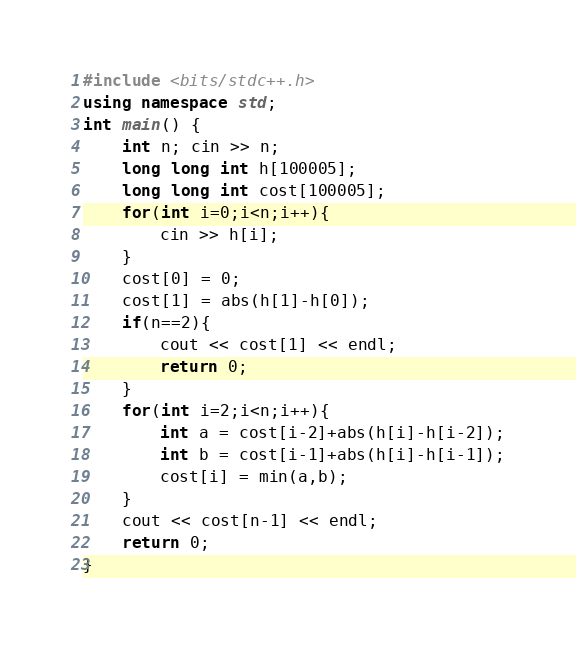Convert code to text. <code><loc_0><loc_0><loc_500><loc_500><_C++_>#include <bits/stdc++.h>
using namespace std;
int main() {
	int n; cin >> n;
	long long int h[100005];
	long long int cost[100005];
	for(int i=0;i<n;i++){
		cin >> h[i];
	}
	cost[0] = 0;
	cost[1] = abs(h[1]-h[0]);
	if(n==2){
		cout << cost[1] << endl;
		return 0;
	}
	for(int i=2;i<n;i++){
		int a = cost[i-2]+abs(h[i]-h[i-2]);
		int b = cost[i-1]+abs(h[i]-h[i-1]);
		cost[i] = min(a,b);
	}
	cout << cost[n-1] << endl;
	return 0;
}
</code> 